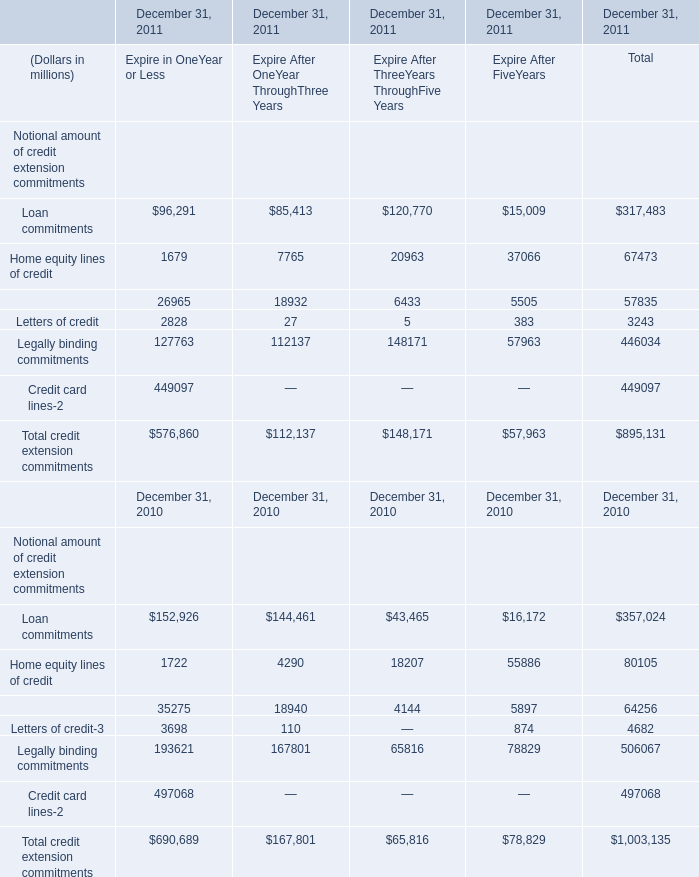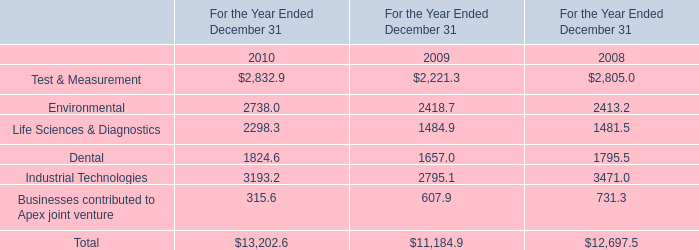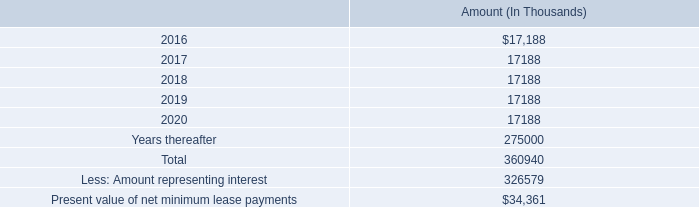The total amount of which section ranks first in 2011 for Expire in OneYear or Less? 
Answer: Total credit extension commitments. 